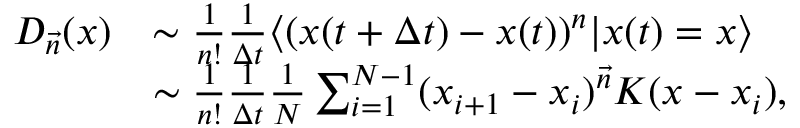<formula> <loc_0><loc_0><loc_500><loc_500>\begin{array} { r l } { D _ { \vec { n } } ( x ) } & { \sim \frac { 1 } { n ! } \frac { 1 } { \Delta t } \langle ( x ( t + \Delta t ) - x ( t ) ) ^ { n } | x ( t ) = x \rangle } \\ & { \sim \frac { 1 } { n ! } \frac { 1 } { \Delta t } \frac { 1 } { N } \sum _ { i = 1 } ^ { N - 1 } ( x _ { i + 1 } - x _ { i } ) ^ { \vec { n } } K ( x - x _ { i } ) , } \end{array}</formula> 